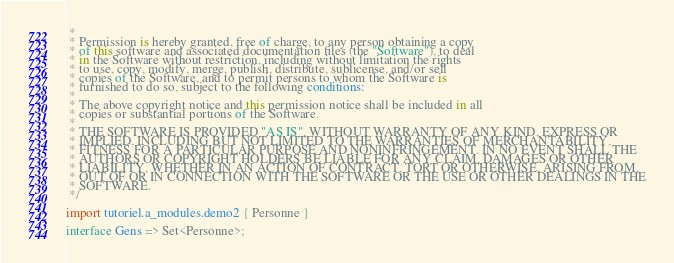Convert code to text. <code><loc_0><loc_0><loc_500><loc_500><_Ceylon_> * 
 * Permission is hereby granted, free of charge, to any person obtaining a copy
 * of this software and associated documentation files (the "Software"), to deal
 * in the Software without restriction, including without limitation the rights
 * to use, copy, modify, merge, publish, distribute, sublicense, and/or sell
 * copies of the Software, and to permit persons to whom the Software is
 * furnished to do so, subject to the following conditions:
 *
 * The above copyright notice and this permission notice shall be included in all
 * copies or substantial portions of the Software.
 *
 * THE SOFTWARE IS PROVIDED "AS IS", WITHOUT WARRANTY OF ANY KIND, EXPRESS OR
 * IMPLIED, INCLUDING BUT NOT LIMITED TO THE WARRANTIES OF MERCHANTABILITY,
 * FITNESS FOR A PARTICULAR PURPOSE AND NONINFRINGEMENT. IN NO EVENT SHALL THE
 * AUTHORS OR COPYRIGHT HOLDERS BE LIABLE FOR ANY CLAIM, DAMAGES OR OTHER
 * LIABILITY, WHETHER IN AN ACTION OF CONTRACT, TORT OR OTHERWISE, ARISING FROM,
 * OUT OF OR IN CONNECTION WITH THE SOFTWARE OR THE USE OR OTHER DEALINGS IN THE
 * SOFTWARE.
 */

import tutoriel.a_modules.demo2 { Personne }

interface Gens => Set<Personne>;
</code> 